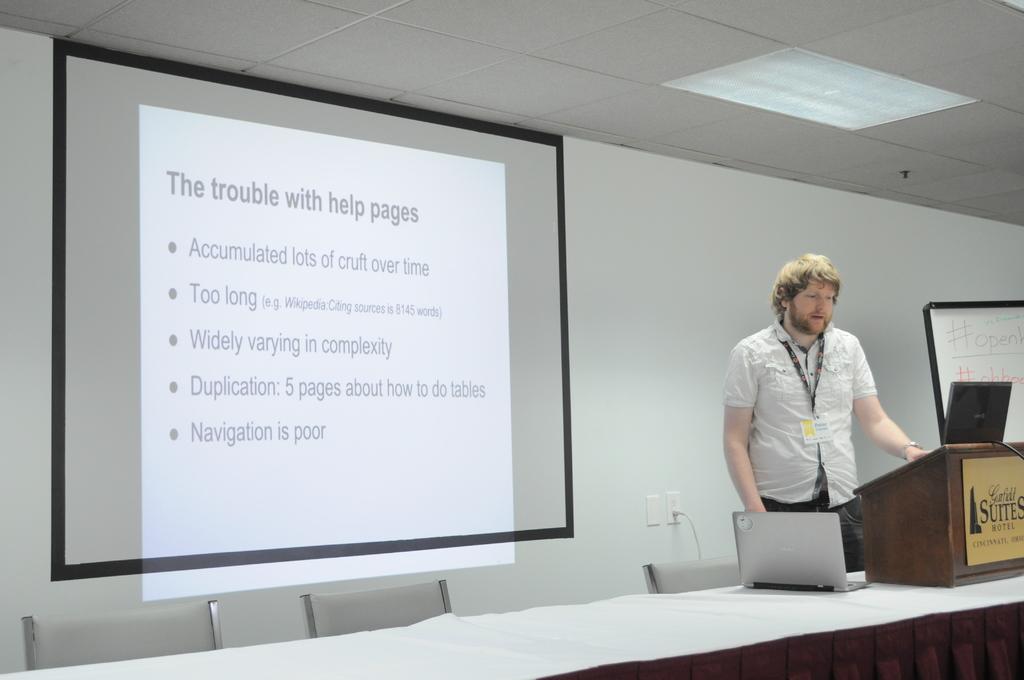Could you give a brief overview of what you see in this image? In this image we can see a man is standing, he is wearing the white shirt, he is wearing the id card, in front here is the table and laptop on it, here is the projector, and something written on it, here are the chairs, at above here is the light. 